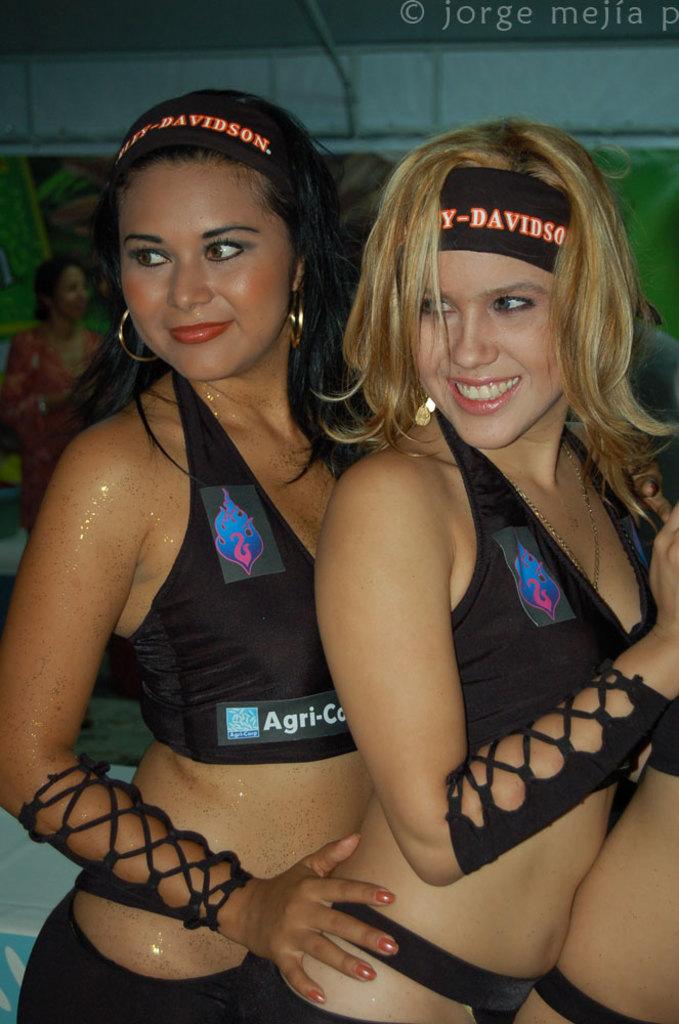What does the top bathing suit say?
Your answer should be very brief. Agri-co. 